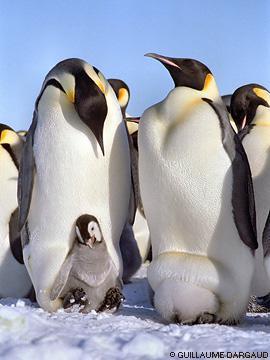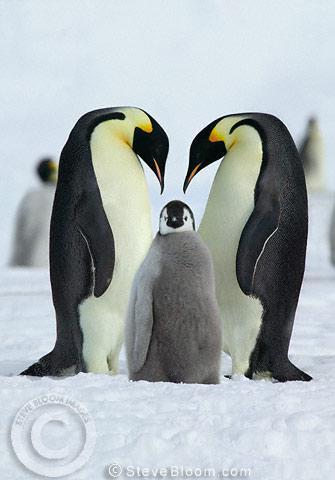The first image is the image on the left, the second image is the image on the right. Analyze the images presented: Is the assertion "An image shows penguin parents with beaks pointed down toward their offspring." valid? Answer yes or no. Yes. 